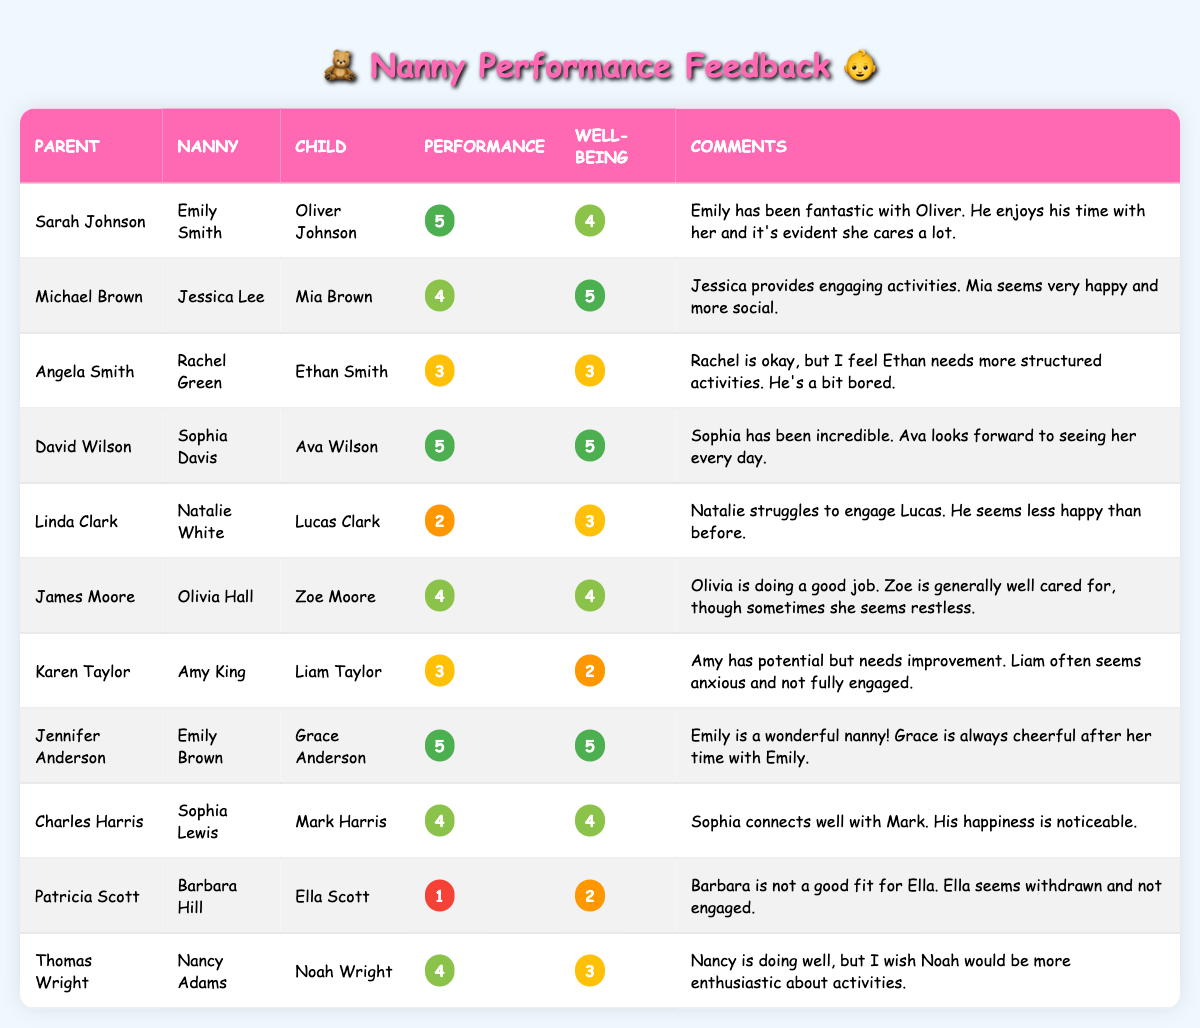What is the performance rating for Emily Smith? The performance rating for Emily Smith is listed directly in the table under her row for Sarah Johnson's feedback, which indicates a performance rating of 5.
Answer: 5 How many nannies received a performance rating of 5? By reviewing the table, I find that there are three instances where the performance rating is 5: Emily Smith, Sophia Davis, and Emily Brown. Therefore, the total count is 3.
Answer: 3 What is the average well-being rating of the children? To calculate the average well-being rating, I sum all the well-being ratings (4 + 5 + 3 + 5 + 3 + 4 + 2 + 5 + 5 + 4 + 2 + 3) which equals 51. Since there are 12 ratings, I divide 51 by 12, giving an average of 4.25.
Answer: 4.25 Did any nanny receive a low performance rating of 1? In the table, Barbara Hill is noted with a performance rating of 1 under Patricia Scott's feedback. This confirms that at least one nanny did receive the lowest rating.
Answer: Yes Which child has shown a drop in engagement according to their parent's feedback? Referring to the table, Liam Taylor under Karen Taylor's feedback indicates a performance rating of 3 and a well-being rating of 2, suggesting that he often seems anxious and not fully engaged. Therefore, Liam Taylor is identified as the child showing a drop in engagement.
Answer: Liam Taylor Which nanny has the highest performance rating and what is it? The table shows that both Emily Smith and Sophia Davis have a performance rating of 5, which is the highest rating recorded. Therefore, the highest performance rating is 5, and it is shared by those two nannies.
Answer: 5 What is the sum of the well-being ratings for children who received a performance rating of 4? First, I identify the nannies with a performance rating of 4, which includes Jessica Lee, Olivia Hall, Sophia Lewis, and Nancy Adams. Their corresponding well-being ratings are 5, 4, 4, and 3 respectively. The sum is 5 + 4 + 4 + 3 = 16.
Answer: 16 How many children are reported to be withdrawn according to their parents? The feedback for Ella Scott under Barbara Hill indicates that she seems withdrawn. Additionally, Liam Taylor is mentioned as often seeming anxious and not fully engaged, which also suggests a level of withdrawal. Thus, two children appear to be reported as withdrawn.
Answer: 2 What are the comments from parents whose children exhibit a well-being rating of 2? Only two children received a well-being rating of 2: Liam Taylor and Ella Scott. Their parents, Karen Taylor and Patricia Scott, commented on Liam's anxiety and Ella's withdrawal, respectively. I can clearly see these comments in the table.
Answer: Liam often seems anxious and not fully engaged; Ella seems withdrawn and not engaged 